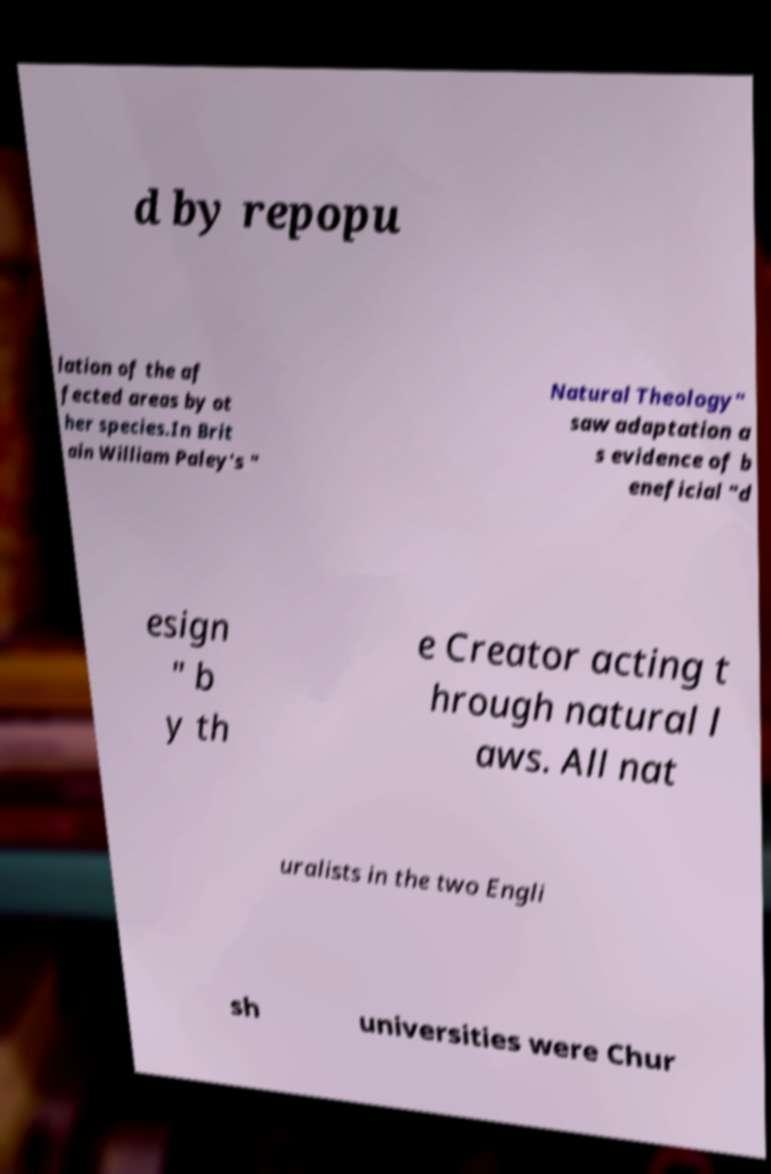What messages or text are displayed in this image? I need them in a readable, typed format. d by repopu lation of the af fected areas by ot her species.In Brit ain William Paley's " Natural Theology" saw adaptation a s evidence of b eneficial "d esign " b y th e Creator acting t hrough natural l aws. All nat uralists in the two Engli sh universities were Chur 